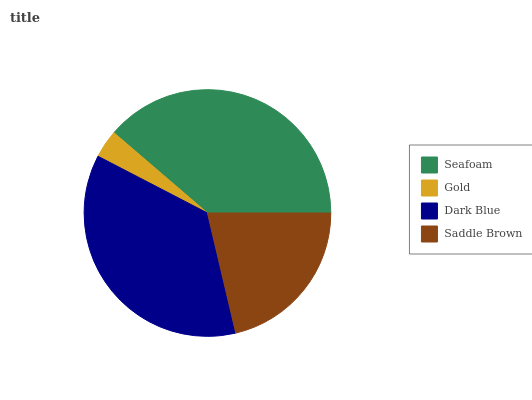Is Gold the minimum?
Answer yes or no. Yes. Is Seafoam the maximum?
Answer yes or no. Yes. Is Dark Blue the minimum?
Answer yes or no. No. Is Dark Blue the maximum?
Answer yes or no. No. Is Dark Blue greater than Gold?
Answer yes or no. Yes. Is Gold less than Dark Blue?
Answer yes or no. Yes. Is Gold greater than Dark Blue?
Answer yes or no. No. Is Dark Blue less than Gold?
Answer yes or no. No. Is Dark Blue the high median?
Answer yes or no. Yes. Is Saddle Brown the low median?
Answer yes or no. Yes. Is Seafoam the high median?
Answer yes or no. No. Is Gold the low median?
Answer yes or no. No. 